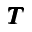<formula> <loc_0><loc_0><loc_500><loc_500>{ \pm b T }</formula> 